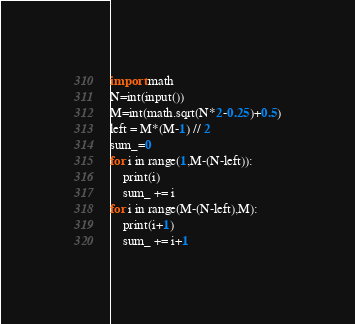<code> <loc_0><loc_0><loc_500><loc_500><_Python_>import math
N=int(input())
M=int(math.sqrt(N*2-0.25)+0.5)
left = M*(M-1) // 2
sum_=0
for i in range(1,M-(N-left)):
    print(i)
    sum_ += i
for i in range(M-(N-left),M):
    print(i+1)
    sum_ += i+1</code> 